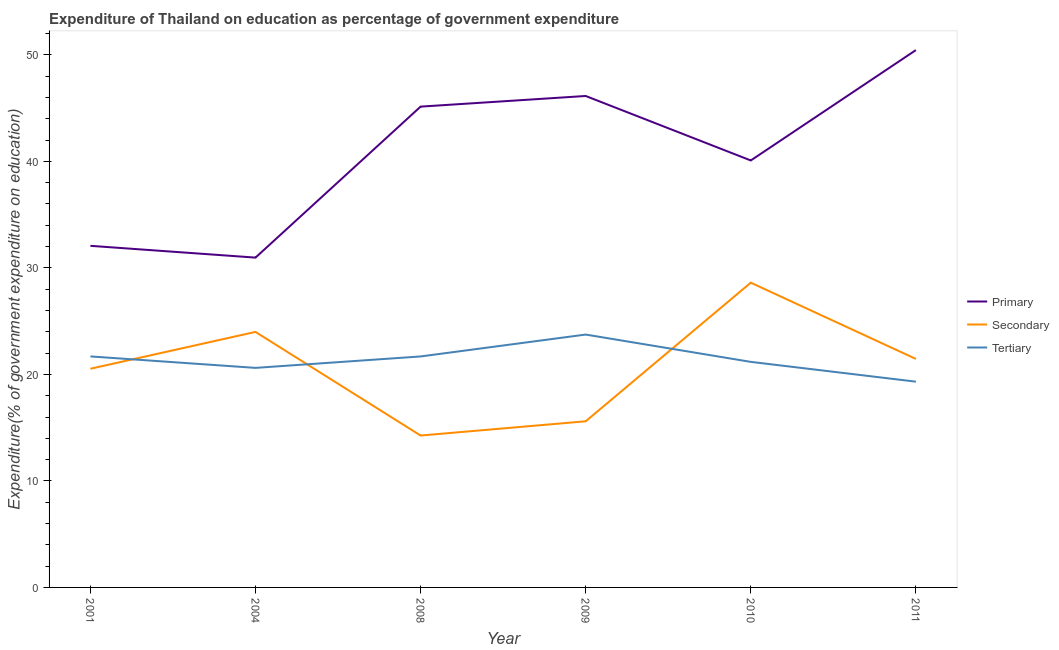Does the line corresponding to expenditure on secondary education intersect with the line corresponding to expenditure on tertiary education?
Provide a short and direct response. Yes. Is the number of lines equal to the number of legend labels?
Ensure brevity in your answer.  Yes. What is the expenditure on secondary education in 2011?
Keep it short and to the point. 21.45. Across all years, what is the maximum expenditure on tertiary education?
Make the answer very short. 23.74. Across all years, what is the minimum expenditure on secondary education?
Keep it short and to the point. 14.26. What is the total expenditure on primary education in the graph?
Your answer should be compact. 244.85. What is the difference between the expenditure on tertiary education in 2004 and that in 2008?
Your answer should be very brief. -1.07. What is the difference between the expenditure on secondary education in 2008 and the expenditure on primary education in 2009?
Make the answer very short. -31.88. What is the average expenditure on secondary education per year?
Your answer should be very brief. 20.74. In the year 2008, what is the difference between the expenditure on secondary education and expenditure on tertiary education?
Offer a terse response. -7.42. What is the ratio of the expenditure on secondary education in 2004 to that in 2011?
Keep it short and to the point. 1.12. What is the difference between the highest and the second highest expenditure on primary education?
Offer a terse response. 4.31. What is the difference between the highest and the lowest expenditure on tertiary education?
Provide a succinct answer. 4.42. Is the expenditure on tertiary education strictly greater than the expenditure on primary education over the years?
Provide a short and direct response. No. Is the expenditure on secondary education strictly less than the expenditure on tertiary education over the years?
Provide a succinct answer. No. How many lines are there?
Provide a succinct answer. 3. How many years are there in the graph?
Give a very brief answer. 6. Are the values on the major ticks of Y-axis written in scientific E-notation?
Your answer should be very brief. No. Where does the legend appear in the graph?
Make the answer very short. Center right. How many legend labels are there?
Offer a very short reply. 3. What is the title of the graph?
Provide a succinct answer. Expenditure of Thailand on education as percentage of government expenditure. Does "Natural Gas" appear as one of the legend labels in the graph?
Your answer should be compact. No. What is the label or title of the X-axis?
Ensure brevity in your answer.  Year. What is the label or title of the Y-axis?
Your answer should be very brief. Expenditure(% of government expenditure on education). What is the Expenditure(% of government expenditure on education) in Primary in 2001?
Offer a terse response. 32.07. What is the Expenditure(% of government expenditure on education) in Secondary in 2001?
Ensure brevity in your answer.  20.53. What is the Expenditure(% of government expenditure on education) in Tertiary in 2001?
Keep it short and to the point. 21.69. What is the Expenditure(% of government expenditure on education) in Primary in 2004?
Your response must be concise. 30.97. What is the Expenditure(% of government expenditure on education) in Secondary in 2004?
Your answer should be compact. 23.99. What is the Expenditure(% of government expenditure on education) of Tertiary in 2004?
Ensure brevity in your answer.  20.61. What is the Expenditure(% of government expenditure on education) in Primary in 2008?
Your response must be concise. 45.14. What is the Expenditure(% of government expenditure on education) in Secondary in 2008?
Your answer should be compact. 14.26. What is the Expenditure(% of government expenditure on education) in Tertiary in 2008?
Your response must be concise. 21.69. What is the Expenditure(% of government expenditure on education) of Primary in 2009?
Provide a succinct answer. 46.14. What is the Expenditure(% of government expenditure on education) of Secondary in 2009?
Make the answer very short. 15.6. What is the Expenditure(% of government expenditure on education) in Tertiary in 2009?
Make the answer very short. 23.74. What is the Expenditure(% of government expenditure on education) in Primary in 2010?
Your answer should be compact. 40.08. What is the Expenditure(% of government expenditure on education) in Secondary in 2010?
Provide a succinct answer. 28.61. What is the Expenditure(% of government expenditure on education) in Tertiary in 2010?
Your answer should be compact. 21.18. What is the Expenditure(% of government expenditure on education) in Primary in 2011?
Offer a terse response. 50.45. What is the Expenditure(% of government expenditure on education) of Secondary in 2011?
Your response must be concise. 21.45. What is the Expenditure(% of government expenditure on education) in Tertiary in 2011?
Provide a short and direct response. 19.32. Across all years, what is the maximum Expenditure(% of government expenditure on education) of Primary?
Keep it short and to the point. 50.45. Across all years, what is the maximum Expenditure(% of government expenditure on education) of Secondary?
Provide a succinct answer. 28.61. Across all years, what is the maximum Expenditure(% of government expenditure on education) of Tertiary?
Keep it short and to the point. 23.74. Across all years, what is the minimum Expenditure(% of government expenditure on education) in Primary?
Provide a short and direct response. 30.97. Across all years, what is the minimum Expenditure(% of government expenditure on education) of Secondary?
Your response must be concise. 14.26. Across all years, what is the minimum Expenditure(% of government expenditure on education) of Tertiary?
Offer a terse response. 19.32. What is the total Expenditure(% of government expenditure on education) of Primary in the graph?
Offer a terse response. 244.85. What is the total Expenditure(% of government expenditure on education) of Secondary in the graph?
Your answer should be compact. 124.44. What is the total Expenditure(% of government expenditure on education) of Tertiary in the graph?
Ensure brevity in your answer.  128.22. What is the difference between the Expenditure(% of government expenditure on education) in Primary in 2001 and that in 2004?
Give a very brief answer. 1.11. What is the difference between the Expenditure(% of government expenditure on education) of Secondary in 2001 and that in 2004?
Give a very brief answer. -3.46. What is the difference between the Expenditure(% of government expenditure on education) in Tertiary in 2001 and that in 2004?
Offer a terse response. 1.07. What is the difference between the Expenditure(% of government expenditure on education) in Primary in 2001 and that in 2008?
Keep it short and to the point. -13.07. What is the difference between the Expenditure(% of government expenditure on education) in Secondary in 2001 and that in 2008?
Your response must be concise. 6.27. What is the difference between the Expenditure(% of government expenditure on education) in Tertiary in 2001 and that in 2008?
Offer a terse response. 0. What is the difference between the Expenditure(% of government expenditure on education) of Primary in 2001 and that in 2009?
Offer a terse response. -14.07. What is the difference between the Expenditure(% of government expenditure on education) of Secondary in 2001 and that in 2009?
Your answer should be very brief. 4.93. What is the difference between the Expenditure(% of government expenditure on education) of Tertiary in 2001 and that in 2009?
Your answer should be compact. -2.05. What is the difference between the Expenditure(% of government expenditure on education) in Primary in 2001 and that in 2010?
Provide a short and direct response. -8.01. What is the difference between the Expenditure(% of government expenditure on education) in Secondary in 2001 and that in 2010?
Ensure brevity in your answer.  -8.08. What is the difference between the Expenditure(% of government expenditure on education) in Tertiary in 2001 and that in 2010?
Offer a terse response. 0.51. What is the difference between the Expenditure(% of government expenditure on education) of Primary in 2001 and that in 2011?
Make the answer very short. -18.38. What is the difference between the Expenditure(% of government expenditure on education) in Secondary in 2001 and that in 2011?
Provide a succinct answer. -0.92. What is the difference between the Expenditure(% of government expenditure on education) in Tertiary in 2001 and that in 2011?
Offer a terse response. 2.37. What is the difference between the Expenditure(% of government expenditure on education) in Primary in 2004 and that in 2008?
Provide a short and direct response. -14.17. What is the difference between the Expenditure(% of government expenditure on education) of Secondary in 2004 and that in 2008?
Make the answer very short. 9.73. What is the difference between the Expenditure(% of government expenditure on education) in Tertiary in 2004 and that in 2008?
Your response must be concise. -1.07. What is the difference between the Expenditure(% of government expenditure on education) of Primary in 2004 and that in 2009?
Provide a short and direct response. -15.17. What is the difference between the Expenditure(% of government expenditure on education) in Secondary in 2004 and that in 2009?
Give a very brief answer. 8.39. What is the difference between the Expenditure(% of government expenditure on education) in Tertiary in 2004 and that in 2009?
Your answer should be very brief. -3.13. What is the difference between the Expenditure(% of government expenditure on education) in Primary in 2004 and that in 2010?
Offer a terse response. -9.12. What is the difference between the Expenditure(% of government expenditure on education) in Secondary in 2004 and that in 2010?
Give a very brief answer. -4.62. What is the difference between the Expenditure(% of government expenditure on education) in Tertiary in 2004 and that in 2010?
Keep it short and to the point. -0.56. What is the difference between the Expenditure(% of government expenditure on education) of Primary in 2004 and that in 2011?
Ensure brevity in your answer.  -19.48. What is the difference between the Expenditure(% of government expenditure on education) of Secondary in 2004 and that in 2011?
Your answer should be very brief. 2.54. What is the difference between the Expenditure(% of government expenditure on education) of Tertiary in 2004 and that in 2011?
Your answer should be compact. 1.29. What is the difference between the Expenditure(% of government expenditure on education) of Primary in 2008 and that in 2009?
Give a very brief answer. -1. What is the difference between the Expenditure(% of government expenditure on education) in Secondary in 2008 and that in 2009?
Keep it short and to the point. -1.34. What is the difference between the Expenditure(% of government expenditure on education) of Tertiary in 2008 and that in 2009?
Your answer should be compact. -2.06. What is the difference between the Expenditure(% of government expenditure on education) of Primary in 2008 and that in 2010?
Give a very brief answer. 5.05. What is the difference between the Expenditure(% of government expenditure on education) of Secondary in 2008 and that in 2010?
Offer a very short reply. -14.35. What is the difference between the Expenditure(% of government expenditure on education) in Tertiary in 2008 and that in 2010?
Ensure brevity in your answer.  0.51. What is the difference between the Expenditure(% of government expenditure on education) of Primary in 2008 and that in 2011?
Keep it short and to the point. -5.31. What is the difference between the Expenditure(% of government expenditure on education) of Secondary in 2008 and that in 2011?
Give a very brief answer. -7.19. What is the difference between the Expenditure(% of government expenditure on education) of Tertiary in 2008 and that in 2011?
Keep it short and to the point. 2.37. What is the difference between the Expenditure(% of government expenditure on education) in Primary in 2009 and that in 2010?
Provide a short and direct response. 6.05. What is the difference between the Expenditure(% of government expenditure on education) of Secondary in 2009 and that in 2010?
Give a very brief answer. -13.01. What is the difference between the Expenditure(% of government expenditure on education) in Tertiary in 2009 and that in 2010?
Offer a terse response. 2.56. What is the difference between the Expenditure(% of government expenditure on education) in Primary in 2009 and that in 2011?
Offer a terse response. -4.31. What is the difference between the Expenditure(% of government expenditure on education) in Secondary in 2009 and that in 2011?
Your answer should be compact. -5.86. What is the difference between the Expenditure(% of government expenditure on education) of Tertiary in 2009 and that in 2011?
Your answer should be very brief. 4.42. What is the difference between the Expenditure(% of government expenditure on education) in Primary in 2010 and that in 2011?
Provide a short and direct response. -10.36. What is the difference between the Expenditure(% of government expenditure on education) in Secondary in 2010 and that in 2011?
Provide a short and direct response. 7.16. What is the difference between the Expenditure(% of government expenditure on education) in Tertiary in 2010 and that in 2011?
Offer a very short reply. 1.86. What is the difference between the Expenditure(% of government expenditure on education) in Primary in 2001 and the Expenditure(% of government expenditure on education) in Secondary in 2004?
Provide a short and direct response. 8.08. What is the difference between the Expenditure(% of government expenditure on education) in Primary in 2001 and the Expenditure(% of government expenditure on education) in Tertiary in 2004?
Your response must be concise. 11.46. What is the difference between the Expenditure(% of government expenditure on education) of Secondary in 2001 and the Expenditure(% of government expenditure on education) of Tertiary in 2004?
Your answer should be very brief. -0.08. What is the difference between the Expenditure(% of government expenditure on education) of Primary in 2001 and the Expenditure(% of government expenditure on education) of Secondary in 2008?
Provide a succinct answer. 17.81. What is the difference between the Expenditure(% of government expenditure on education) of Primary in 2001 and the Expenditure(% of government expenditure on education) of Tertiary in 2008?
Make the answer very short. 10.38. What is the difference between the Expenditure(% of government expenditure on education) of Secondary in 2001 and the Expenditure(% of government expenditure on education) of Tertiary in 2008?
Keep it short and to the point. -1.15. What is the difference between the Expenditure(% of government expenditure on education) in Primary in 2001 and the Expenditure(% of government expenditure on education) in Secondary in 2009?
Give a very brief answer. 16.47. What is the difference between the Expenditure(% of government expenditure on education) of Primary in 2001 and the Expenditure(% of government expenditure on education) of Tertiary in 2009?
Ensure brevity in your answer.  8.33. What is the difference between the Expenditure(% of government expenditure on education) of Secondary in 2001 and the Expenditure(% of government expenditure on education) of Tertiary in 2009?
Give a very brief answer. -3.21. What is the difference between the Expenditure(% of government expenditure on education) in Primary in 2001 and the Expenditure(% of government expenditure on education) in Secondary in 2010?
Your response must be concise. 3.46. What is the difference between the Expenditure(% of government expenditure on education) of Primary in 2001 and the Expenditure(% of government expenditure on education) of Tertiary in 2010?
Your answer should be very brief. 10.89. What is the difference between the Expenditure(% of government expenditure on education) of Secondary in 2001 and the Expenditure(% of government expenditure on education) of Tertiary in 2010?
Make the answer very short. -0.64. What is the difference between the Expenditure(% of government expenditure on education) in Primary in 2001 and the Expenditure(% of government expenditure on education) in Secondary in 2011?
Provide a succinct answer. 10.62. What is the difference between the Expenditure(% of government expenditure on education) of Primary in 2001 and the Expenditure(% of government expenditure on education) of Tertiary in 2011?
Your answer should be very brief. 12.75. What is the difference between the Expenditure(% of government expenditure on education) in Secondary in 2001 and the Expenditure(% of government expenditure on education) in Tertiary in 2011?
Ensure brevity in your answer.  1.21. What is the difference between the Expenditure(% of government expenditure on education) of Primary in 2004 and the Expenditure(% of government expenditure on education) of Secondary in 2008?
Your response must be concise. 16.7. What is the difference between the Expenditure(% of government expenditure on education) of Primary in 2004 and the Expenditure(% of government expenditure on education) of Tertiary in 2008?
Make the answer very short. 9.28. What is the difference between the Expenditure(% of government expenditure on education) of Secondary in 2004 and the Expenditure(% of government expenditure on education) of Tertiary in 2008?
Give a very brief answer. 2.3. What is the difference between the Expenditure(% of government expenditure on education) of Primary in 2004 and the Expenditure(% of government expenditure on education) of Secondary in 2009?
Keep it short and to the point. 15.37. What is the difference between the Expenditure(% of government expenditure on education) of Primary in 2004 and the Expenditure(% of government expenditure on education) of Tertiary in 2009?
Give a very brief answer. 7.22. What is the difference between the Expenditure(% of government expenditure on education) in Secondary in 2004 and the Expenditure(% of government expenditure on education) in Tertiary in 2009?
Give a very brief answer. 0.25. What is the difference between the Expenditure(% of government expenditure on education) in Primary in 2004 and the Expenditure(% of government expenditure on education) in Secondary in 2010?
Your response must be concise. 2.35. What is the difference between the Expenditure(% of government expenditure on education) in Primary in 2004 and the Expenditure(% of government expenditure on education) in Tertiary in 2010?
Provide a succinct answer. 9.79. What is the difference between the Expenditure(% of government expenditure on education) in Secondary in 2004 and the Expenditure(% of government expenditure on education) in Tertiary in 2010?
Your answer should be very brief. 2.81. What is the difference between the Expenditure(% of government expenditure on education) in Primary in 2004 and the Expenditure(% of government expenditure on education) in Secondary in 2011?
Give a very brief answer. 9.51. What is the difference between the Expenditure(% of government expenditure on education) in Primary in 2004 and the Expenditure(% of government expenditure on education) in Tertiary in 2011?
Your answer should be compact. 11.65. What is the difference between the Expenditure(% of government expenditure on education) of Secondary in 2004 and the Expenditure(% of government expenditure on education) of Tertiary in 2011?
Provide a short and direct response. 4.67. What is the difference between the Expenditure(% of government expenditure on education) in Primary in 2008 and the Expenditure(% of government expenditure on education) in Secondary in 2009?
Make the answer very short. 29.54. What is the difference between the Expenditure(% of government expenditure on education) of Primary in 2008 and the Expenditure(% of government expenditure on education) of Tertiary in 2009?
Offer a terse response. 21.4. What is the difference between the Expenditure(% of government expenditure on education) in Secondary in 2008 and the Expenditure(% of government expenditure on education) in Tertiary in 2009?
Offer a terse response. -9.48. What is the difference between the Expenditure(% of government expenditure on education) of Primary in 2008 and the Expenditure(% of government expenditure on education) of Secondary in 2010?
Ensure brevity in your answer.  16.53. What is the difference between the Expenditure(% of government expenditure on education) of Primary in 2008 and the Expenditure(% of government expenditure on education) of Tertiary in 2010?
Make the answer very short. 23.96. What is the difference between the Expenditure(% of government expenditure on education) in Secondary in 2008 and the Expenditure(% of government expenditure on education) in Tertiary in 2010?
Ensure brevity in your answer.  -6.92. What is the difference between the Expenditure(% of government expenditure on education) of Primary in 2008 and the Expenditure(% of government expenditure on education) of Secondary in 2011?
Offer a very short reply. 23.69. What is the difference between the Expenditure(% of government expenditure on education) of Primary in 2008 and the Expenditure(% of government expenditure on education) of Tertiary in 2011?
Keep it short and to the point. 25.82. What is the difference between the Expenditure(% of government expenditure on education) of Secondary in 2008 and the Expenditure(% of government expenditure on education) of Tertiary in 2011?
Offer a terse response. -5.06. What is the difference between the Expenditure(% of government expenditure on education) of Primary in 2009 and the Expenditure(% of government expenditure on education) of Secondary in 2010?
Your answer should be compact. 17.53. What is the difference between the Expenditure(% of government expenditure on education) of Primary in 2009 and the Expenditure(% of government expenditure on education) of Tertiary in 2010?
Keep it short and to the point. 24.96. What is the difference between the Expenditure(% of government expenditure on education) in Secondary in 2009 and the Expenditure(% of government expenditure on education) in Tertiary in 2010?
Offer a very short reply. -5.58. What is the difference between the Expenditure(% of government expenditure on education) of Primary in 2009 and the Expenditure(% of government expenditure on education) of Secondary in 2011?
Make the answer very short. 24.69. What is the difference between the Expenditure(% of government expenditure on education) in Primary in 2009 and the Expenditure(% of government expenditure on education) in Tertiary in 2011?
Keep it short and to the point. 26.82. What is the difference between the Expenditure(% of government expenditure on education) in Secondary in 2009 and the Expenditure(% of government expenditure on education) in Tertiary in 2011?
Give a very brief answer. -3.72. What is the difference between the Expenditure(% of government expenditure on education) in Primary in 2010 and the Expenditure(% of government expenditure on education) in Secondary in 2011?
Your answer should be very brief. 18.63. What is the difference between the Expenditure(% of government expenditure on education) in Primary in 2010 and the Expenditure(% of government expenditure on education) in Tertiary in 2011?
Provide a short and direct response. 20.77. What is the difference between the Expenditure(% of government expenditure on education) of Secondary in 2010 and the Expenditure(% of government expenditure on education) of Tertiary in 2011?
Offer a terse response. 9.29. What is the average Expenditure(% of government expenditure on education) in Primary per year?
Ensure brevity in your answer.  40.81. What is the average Expenditure(% of government expenditure on education) of Secondary per year?
Keep it short and to the point. 20.74. What is the average Expenditure(% of government expenditure on education) in Tertiary per year?
Your answer should be compact. 21.37. In the year 2001, what is the difference between the Expenditure(% of government expenditure on education) of Primary and Expenditure(% of government expenditure on education) of Secondary?
Make the answer very short. 11.54. In the year 2001, what is the difference between the Expenditure(% of government expenditure on education) in Primary and Expenditure(% of government expenditure on education) in Tertiary?
Offer a very short reply. 10.38. In the year 2001, what is the difference between the Expenditure(% of government expenditure on education) of Secondary and Expenditure(% of government expenditure on education) of Tertiary?
Offer a very short reply. -1.16. In the year 2004, what is the difference between the Expenditure(% of government expenditure on education) in Primary and Expenditure(% of government expenditure on education) in Secondary?
Your answer should be very brief. 6.98. In the year 2004, what is the difference between the Expenditure(% of government expenditure on education) in Primary and Expenditure(% of government expenditure on education) in Tertiary?
Keep it short and to the point. 10.35. In the year 2004, what is the difference between the Expenditure(% of government expenditure on education) in Secondary and Expenditure(% of government expenditure on education) in Tertiary?
Your response must be concise. 3.38. In the year 2008, what is the difference between the Expenditure(% of government expenditure on education) in Primary and Expenditure(% of government expenditure on education) in Secondary?
Provide a short and direct response. 30.88. In the year 2008, what is the difference between the Expenditure(% of government expenditure on education) in Primary and Expenditure(% of government expenditure on education) in Tertiary?
Make the answer very short. 23.45. In the year 2008, what is the difference between the Expenditure(% of government expenditure on education) of Secondary and Expenditure(% of government expenditure on education) of Tertiary?
Ensure brevity in your answer.  -7.42. In the year 2009, what is the difference between the Expenditure(% of government expenditure on education) of Primary and Expenditure(% of government expenditure on education) of Secondary?
Keep it short and to the point. 30.54. In the year 2009, what is the difference between the Expenditure(% of government expenditure on education) of Primary and Expenditure(% of government expenditure on education) of Tertiary?
Make the answer very short. 22.4. In the year 2009, what is the difference between the Expenditure(% of government expenditure on education) of Secondary and Expenditure(% of government expenditure on education) of Tertiary?
Provide a succinct answer. -8.14. In the year 2010, what is the difference between the Expenditure(% of government expenditure on education) in Primary and Expenditure(% of government expenditure on education) in Secondary?
Give a very brief answer. 11.47. In the year 2010, what is the difference between the Expenditure(% of government expenditure on education) of Primary and Expenditure(% of government expenditure on education) of Tertiary?
Your answer should be compact. 18.91. In the year 2010, what is the difference between the Expenditure(% of government expenditure on education) of Secondary and Expenditure(% of government expenditure on education) of Tertiary?
Provide a short and direct response. 7.44. In the year 2011, what is the difference between the Expenditure(% of government expenditure on education) in Primary and Expenditure(% of government expenditure on education) in Secondary?
Offer a very short reply. 28.99. In the year 2011, what is the difference between the Expenditure(% of government expenditure on education) of Primary and Expenditure(% of government expenditure on education) of Tertiary?
Offer a very short reply. 31.13. In the year 2011, what is the difference between the Expenditure(% of government expenditure on education) in Secondary and Expenditure(% of government expenditure on education) in Tertiary?
Offer a terse response. 2.13. What is the ratio of the Expenditure(% of government expenditure on education) of Primary in 2001 to that in 2004?
Make the answer very short. 1.04. What is the ratio of the Expenditure(% of government expenditure on education) of Secondary in 2001 to that in 2004?
Offer a terse response. 0.86. What is the ratio of the Expenditure(% of government expenditure on education) in Tertiary in 2001 to that in 2004?
Keep it short and to the point. 1.05. What is the ratio of the Expenditure(% of government expenditure on education) of Primary in 2001 to that in 2008?
Ensure brevity in your answer.  0.71. What is the ratio of the Expenditure(% of government expenditure on education) of Secondary in 2001 to that in 2008?
Provide a short and direct response. 1.44. What is the ratio of the Expenditure(% of government expenditure on education) in Tertiary in 2001 to that in 2008?
Your answer should be very brief. 1. What is the ratio of the Expenditure(% of government expenditure on education) in Primary in 2001 to that in 2009?
Your response must be concise. 0.7. What is the ratio of the Expenditure(% of government expenditure on education) of Secondary in 2001 to that in 2009?
Your answer should be compact. 1.32. What is the ratio of the Expenditure(% of government expenditure on education) in Tertiary in 2001 to that in 2009?
Give a very brief answer. 0.91. What is the ratio of the Expenditure(% of government expenditure on education) in Primary in 2001 to that in 2010?
Your response must be concise. 0.8. What is the ratio of the Expenditure(% of government expenditure on education) in Secondary in 2001 to that in 2010?
Your response must be concise. 0.72. What is the ratio of the Expenditure(% of government expenditure on education) in Tertiary in 2001 to that in 2010?
Ensure brevity in your answer.  1.02. What is the ratio of the Expenditure(% of government expenditure on education) in Primary in 2001 to that in 2011?
Offer a very short reply. 0.64. What is the ratio of the Expenditure(% of government expenditure on education) of Secondary in 2001 to that in 2011?
Your response must be concise. 0.96. What is the ratio of the Expenditure(% of government expenditure on education) in Tertiary in 2001 to that in 2011?
Make the answer very short. 1.12. What is the ratio of the Expenditure(% of government expenditure on education) of Primary in 2004 to that in 2008?
Your answer should be very brief. 0.69. What is the ratio of the Expenditure(% of government expenditure on education) of Secondary in 2004 to that in 2008?
Make the answer very short. 1.68. What is the ratio of the Expenditure(% of government expenditure on education) in Tertiary in 2004 to that in 2008?
Provide a succinct answer. 0.95. What is the ratio of the Expenditure(% of government expenditure on education) in Primary in 2004 to that in 2009?
Your answer should be very brief. 0.67. What is the ratio of the Expenditure(% of government expenditure on education) of Secondary in 2004 to that in 2009?
Offer a terse response. 1.54. What is the ratio of the Expenditure(% of government expenditure on education) in Tertiary in 2004 to that in 2009?
Provide a short and direct response. 0.87. What is the ratio of the Expenditure(% of government expenditure on education) in Primary in 2004 to that in 2010?
Offer a very short reply. 0.77. What is the ratio of the Expenditure(% of government expenditure on education) in Secondary in 2004 to that in 2010?
Your answer should be compact. 0.84. What is the ratio of the Expenditure(% of government expenditure on education) of Tertiary in 2004 to that in 2010?
Offer a terse response. 0.97. What is the ratio of the Expenditure(% of government expenditure on education) of Primary in 2004 to that in 2011?
Make the answer very short. 0.61. What is the ratio of the Expenditure(% of government expenditure on education) of Secondary in 2004 to that in 2011?
Your answer should be very brief. 1.12. What is the ratio of the Expenditure(% of government expenditure on education) in Tertiary in 2004 to that in 2011?
Your response must be concise. 1.07. What is the ratio of the Expenditure(% of government expenditure on education) in Primary in 2008 to that in 2009?
Make the answer very short. 0.98. What is the ratio of the Expenditure(% of government expenditure on education) of Secondary in 2008 to that in 2009?
Your answer should be compact. 0.91. What is the ratio of the Expenditure(% of government expenditure on education) of Tertiary in 2008 to that in 2009?
Make the answer very short. 0.91. What is the ratio of the Expenditure(% of government expenditure on education) of Primary in 2008 to that in 2010?
Provide a succinct answer. 1.13. What is the ratio of the Expenditure(% of government expenditure on education) of Secondary in 2008 to that in 2010?
Your answer should be compact. 0.5. What is the ratio of the Expenditure(% of government expenditure on education) of Tertiary in 2008 to that in 2010?
Offer a very short reply. 1.02. What is the ratio of the Expenditure(% of government expenditure on education) of Primary in 2008 to that in 2011?
Make the answer very short. 0.89. What is the ratio of the Expenditure(% of government expenditure on education) of Secondary in 2008 to that in 2011?
Give a very brief answer. 0.66. What is the ratio of the Expenditure(% of government expenditure on education) in Tertiary in 2008 to that in 2011?
Keep it short and to the point. 1.12. What is the ratio of the Expenditure(% of government expenditure on education) of Primary in 2009 to that in 2010?
Your answer should be very brief. 1.15. What is the ratio of the Expenditure(% of government expenditure on education) in Secondary in 2009 to that in 2010?
Give a very brief answer. 0.55. What is the ratio of the Expenditure(% of government expenditure on education) in Tertiary in 2009 to that in 2010?
Offer a terse response. 1.12. What is the ratio of the Expenditure(% of government expenditure on education) of Primary in 2009 to that in 2011?
Provide a short and direct response. 0.91. What is the ratio of the Expenditure(% of government expenditure on education) in Secondary in 2009 to that in 2011?
Offer a very short reply. 0.73. What is the ratio of the Expenditure(% of government expenditure on education) in Tertiary in 2009 to that in 2011?
Keep it short and to the point. 1.23. What is the ratio of the Expenditure(% of government expenditure on education) in Primary in 2010 to that in 2011?
Offer a very short reply. 0.79. What is the ratio of the Expenditure(% of government expenditure on education) of Secondary in 2010 to that in 2011?
Give a very brief answer. 1.33. What is the ratio of the Expenditure(% of government expenditure on education) of Tertiary in 2010 to that in 2011?
Make the answer very short. 1.1. What is the difference between the highest and the second highest Expenditure(% of government expenditure on education) in Primary?
Make the answer very short. 4.31. What is the difference between the highest and the second highest Expenditure(% of government expenditure on education) of Secondary?
Your answer should be very brief. 4.62. What is the difference between the highest and the second highest Expenditure(% of government expenditure on education) in Tertiary?
Offer a very short reply. 2.05. What is the difference between the highest and the lowest Expenditure(% of government expenditure on education) in Primary?
Offer a terse response. 19.48. What is the difference between the highest and the lowest Expenditure(% of government expenditure on education) of Secondary?
Provide a short and direct response. 14.35. What is the difference between the highest and the lowest Expenditure(% of government expenditure on education) of Tertiary?
Ensure brevity in your answer.  4.42. 